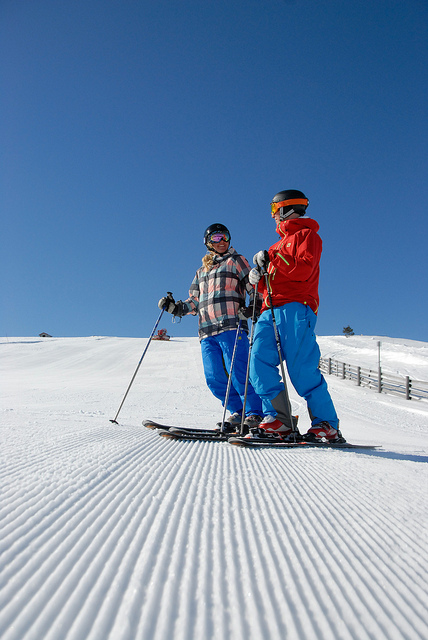What winter sport are the individuals engaged in? The individuals are skiing, which is evident from the ski equipment they're using and the snowy slope they're on.  Is it possible to tell if they're beginners or experienced skiers? From the image alone, identifying skill level can be challenging; however, their poised stance and the gear they have suggest they might be at least intermediate skiers. 